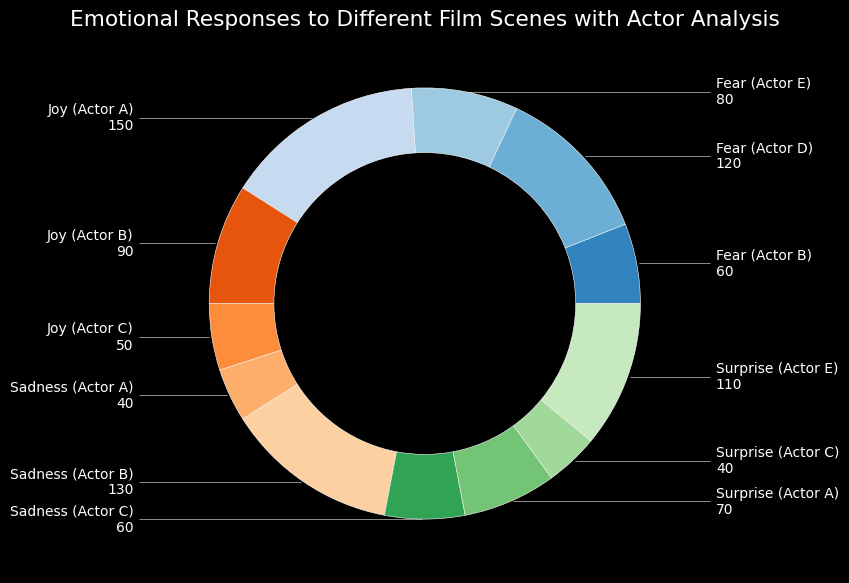What emotion had the least count across all actors? Look at the chart sections labeled with different emotions. Identify which emotion has the smallest aggregated count across all listed actors.
Answer: Surprise (Actor C) Which actor induced the most joy? Identify the sections that correspond to the "joy" emotion. Find the actor associated with the largest count within this emotion.
Answer: Actor A Which segment shows Actors evoking fear the most and how many? Look at the sections colored to represent different fear-inducing actors. Identify which actor has the highest count and note the value.
Answer: Actor D, 120 Which emotion is most associated with Actor A? Observe the slices where Actor A appears. Compare the heights and identify which is tallest (indicating the highest count).
Answer: Joy Does Actor C evoke surprise more than joy? Compare the counts associated with Actor C for surprise and joy. Determine if the surprise count is higher than the joy count.
Answer: No (Surprise: 40, Joy: 50) Who is associated with the least sadness, and what is the count? Look at the segments relating to sadness and find which actor has the smallest count.
Answer: Actor A, 40 What's the difference in the aggregated count of fear versus sadness? Sum up all the counts associated with fear and sadness. Then, calculate the difference between these two sums.  Fear: (120 + 80 + 60) = 260, Sadness: (130 + 40 + 60) = 230. Difference: 260 - 230
Answer: 30 Which actor has the most balanced distribution of emotions? Compare the segments for each actor and identify who has the most consistent (balanced) counts across different emotions. Actor C's counts (50, 60, and 40) seem relatively close.
Answer: Actor C Does Actor E have a higher count in fear or surprise? Look at Actor E's segments, one for fear (thriller) and one for surprise (thriller) and compare them.
Answer: Surprise (110 vs 80) 